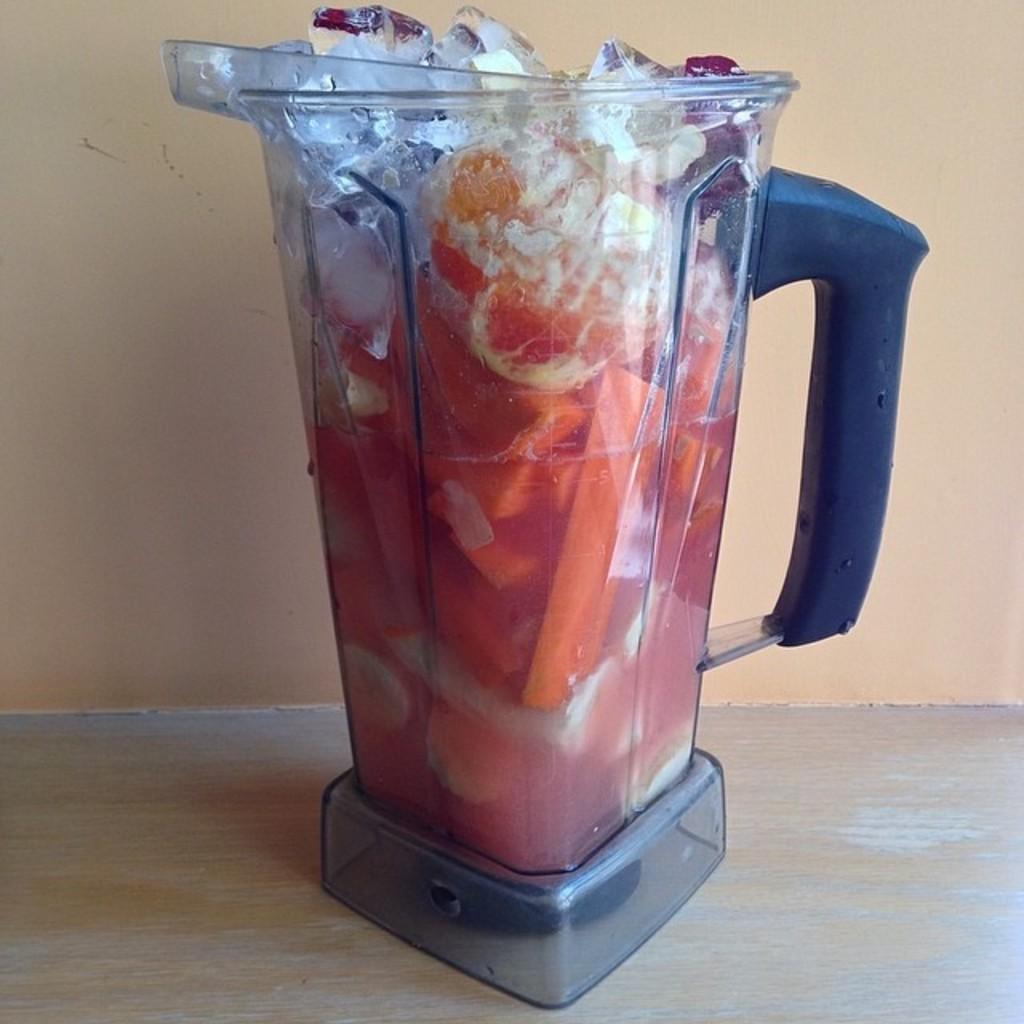Please provide a concise description of this image. In this picture I can observe a jar. In this jar there are some fruits and ice cubes are placed. The jar is placed on the cream color surface. In the background there is a wall. 